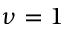Convert formula to latex. <formula><loc_0><loc_0><loc_500><loc_500>\nu = 1</formula> 